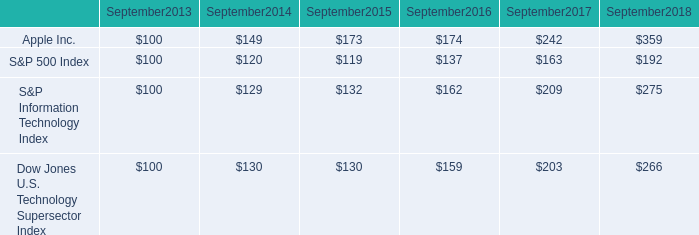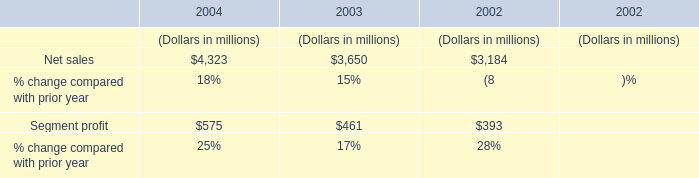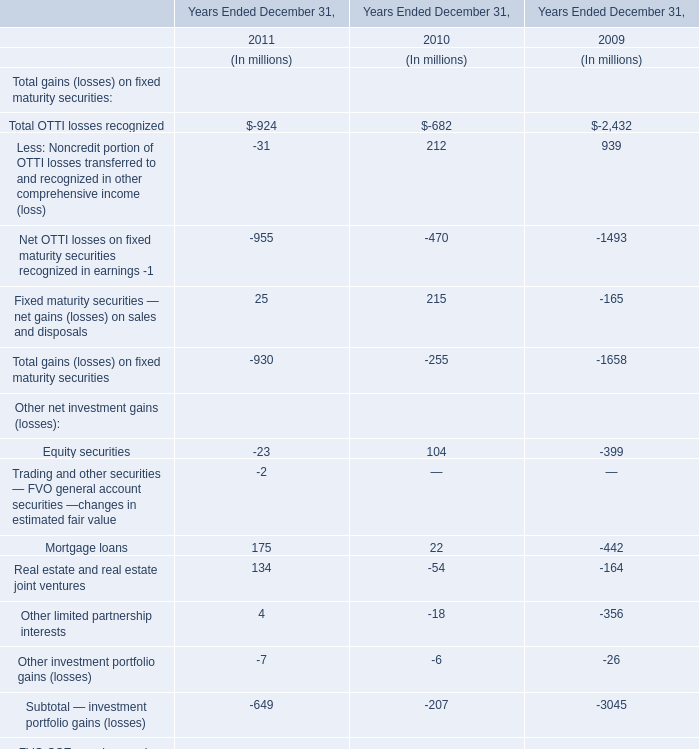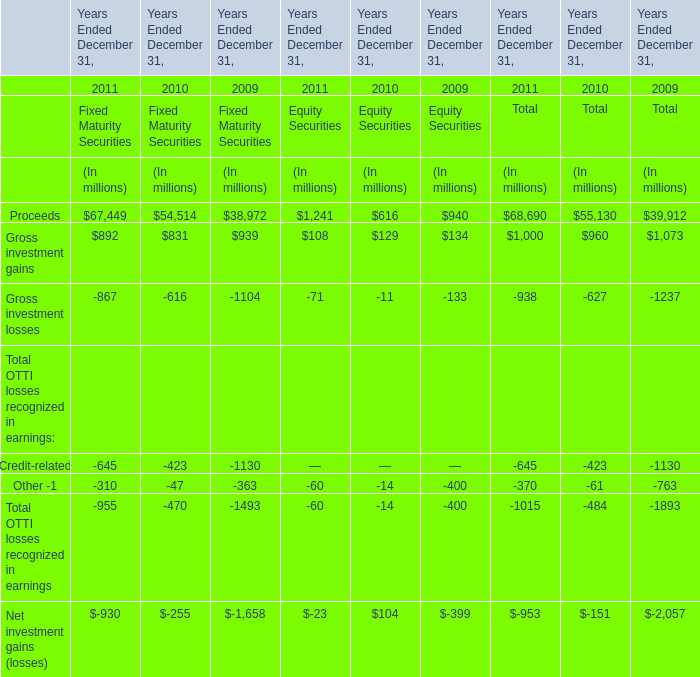What was the average of Other -1 for Years Ended December 31 in 2011, 2010, and 2009? (in million) 
Computations: (((-60 - 14) - 400) / 3)
Answer: -158.0. 